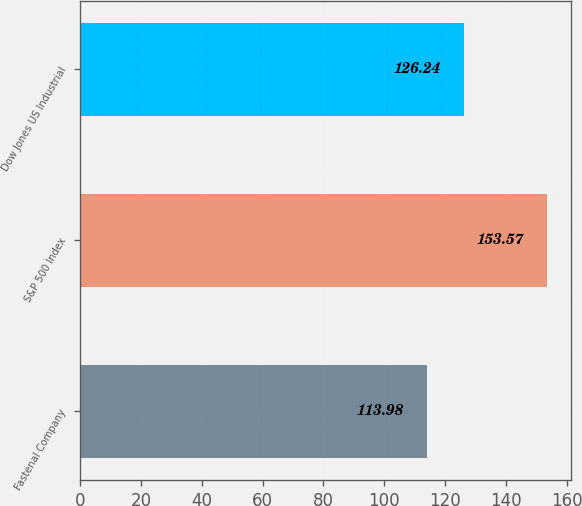<chart> <loc_0><loc_0><loc_500><loc_500><bar_chart><fcel>Fastenal Company<fcel>S&P 500 Index<fcel>Dow Jones US Industrial<nl><fcel>113.98<fcel>153.57<fcel>126.24<nl></chart> 